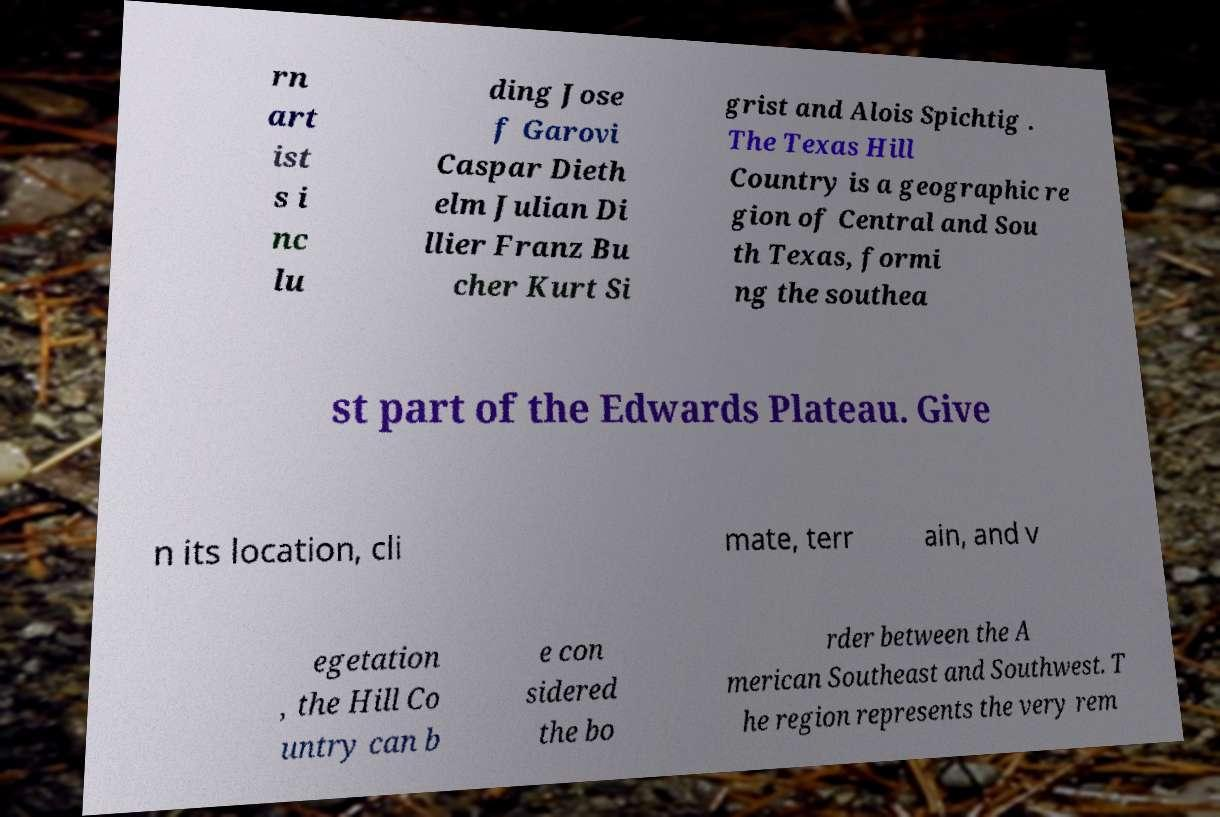Please read and relay the text visible in this image. What does it say? rn art ist s i nc lu ding Jose f Garovi Caspar Dieth elm Julian Di llier Franz Bu cher Kurt Si grist and Alois Spichtig . The Texas Hill Country is a geographic re gion of Central and Sou th Texas, formi ng the southea st part of the Edwards Plateau. Give n its location, cli mate, terr ain, and v egetation , the Hill Co untry can b e con sidered the bo rder between the A merican Southeast and Southwest. T he region represents the very rem 